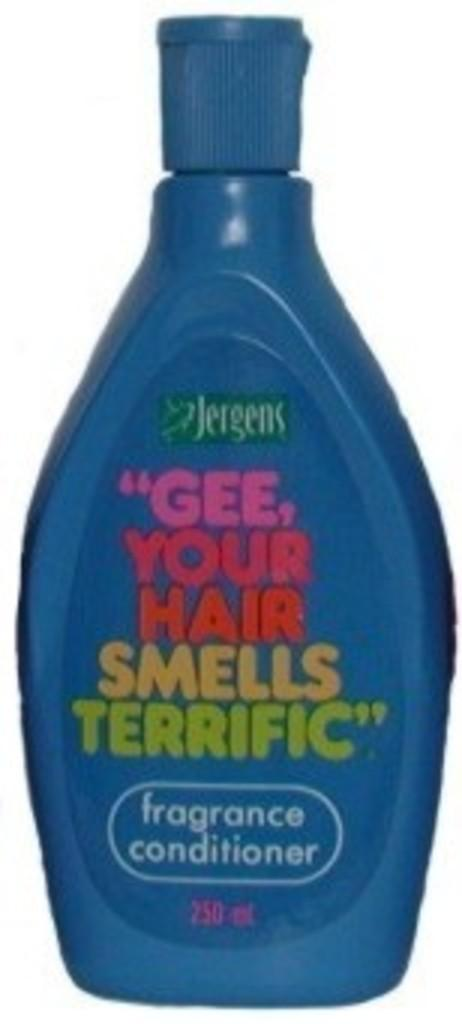<image>
Relay a brief, clear account of the picture shown. A bottle of hair conditioner called Gee Your Hair Smells Terrific. 